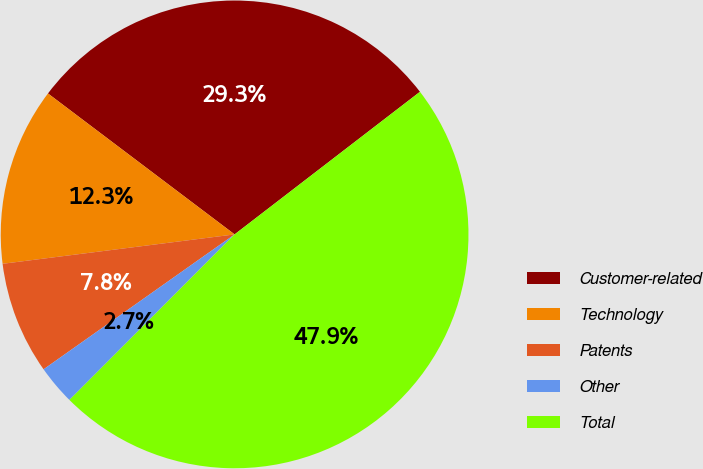Convert chart. <chart><loc_0><loc_0><loc_500><loc_500><pie_chart><fcel>Customer-related<fcel>Technology<fcel>Patents<fcel>Other<fcel>Total<nl><fcel>29.27%<fcel>12.3%<fcel>7.78%<fcel>2.73%<fcel>47.92%<nl></chart> 